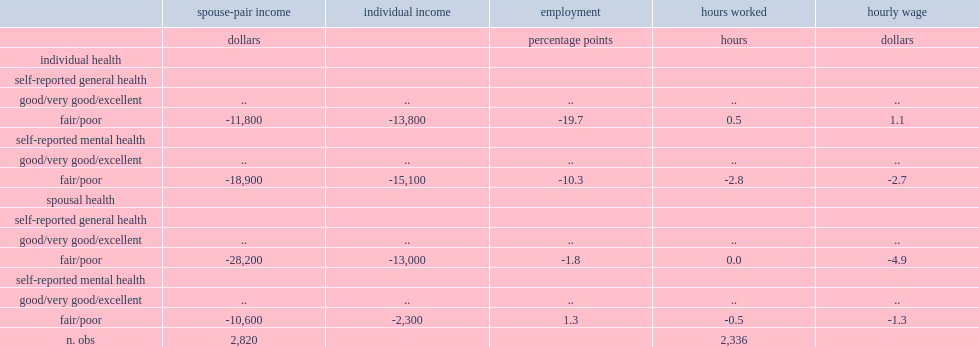What was the number difference between men with poor general health andmen with good to excellent general health in spouse-pair income ? -11800.0. What was the percent difference between men with poor general health and men with good to excellent general health who were employed? -19.7. What was the percent difference between men with poor mental health and men with good mental health who were employed? -10.3. What was the number difference between a spouse with poor general health and those with good general health in spouse-pair income? -28200.0. What was the number difference between a spouse with poor mental health and those with good mental health in spouse-pair income? -10600.0. 